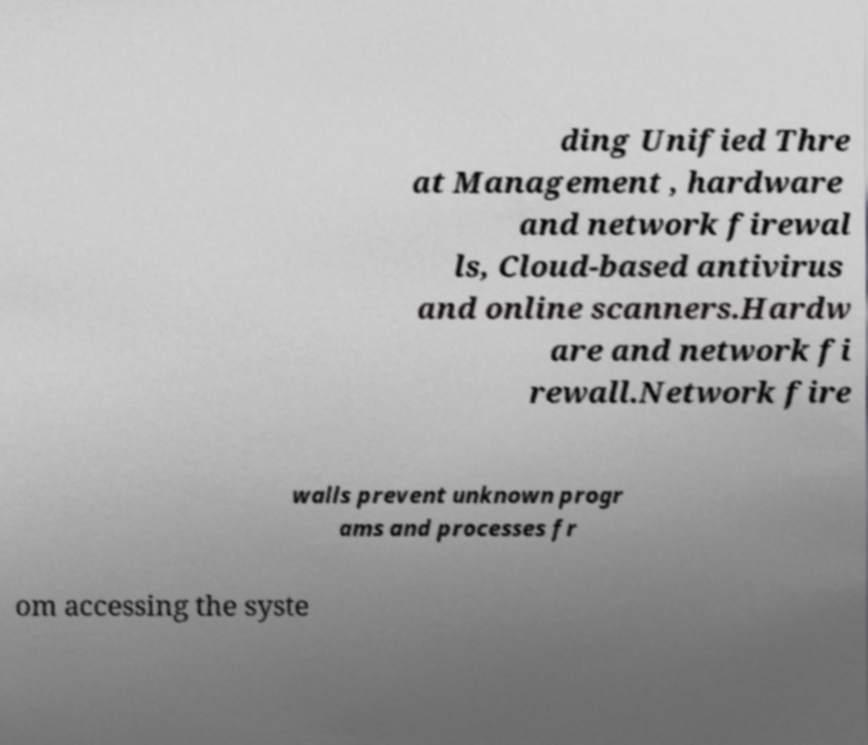Could you extract and type out the text from this image? ding Unified Thre at Management , hardware and network firewal ls, Cloud-based antivirus and online scanners.Hardw are and network fi rewall.Network fire walls prevent unknown progr ams and processes fr om accessing the syste 